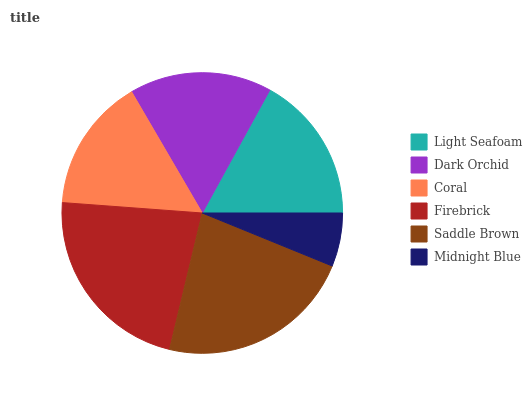Is Midnight Blue the minimum?
Answer yes or no. Yes. Is Saddle Brown the maximum?
Answer yes or no. Yes. Is Dark Orchid the minimum?
Answer yes or no. No. Is Dark Orchid the maximum?
Answer yes or no. No. Is Light Seafoam greater than Dark Orchid?
Answer yes or no. Yes. Is Dark Orchid less than Light Seafoam?
Answer yes or no. Yes. Is Dark Orchid greater than Light Seafoam?
Answer yes or no. No. Is Light Seafoam less than Dark Orchid?
Answer yes or no. No. Is Light Seafoam the high median?
Answer yes or no. Yes. Is Dark Orchid the low median?
Answer yes or no. Yes. Is Saddle Brown the high median?
Answer yes or no. No. Is Midnight Blue the low median?
Answer yes or no. No. 